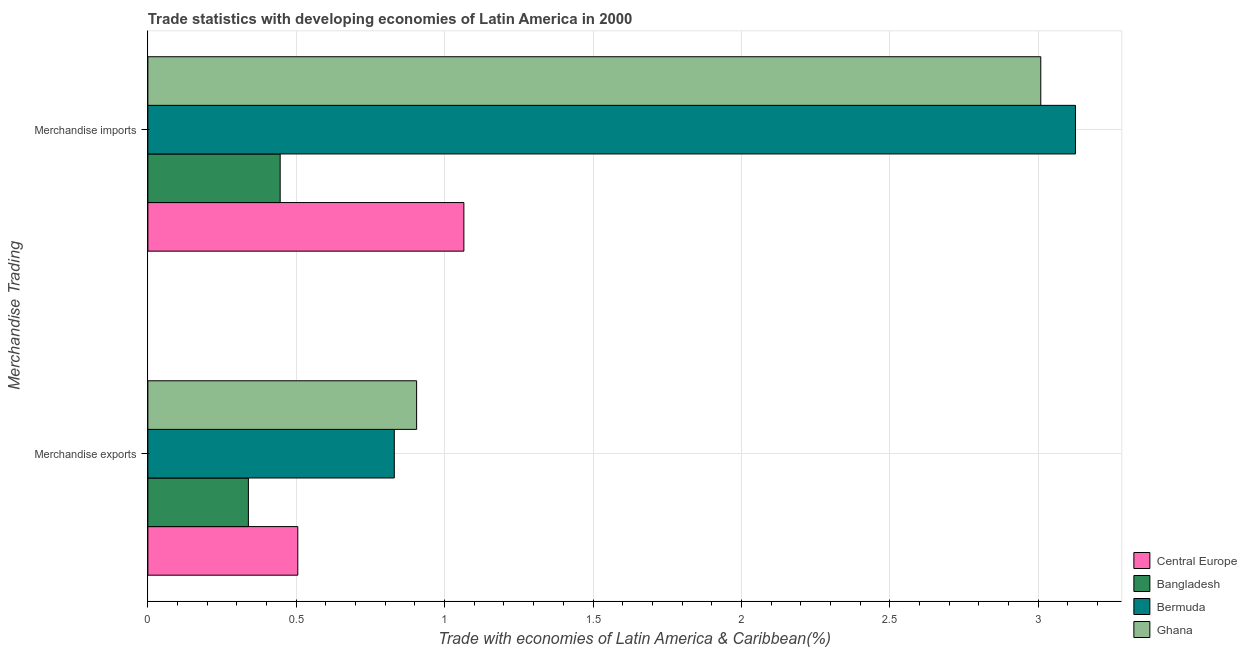Are the number of bars on each tick of the Y-axis equal?
Your answer should be compact. Yes. How many bars are there on the 1st tick from the bottom?
Provide a succinct answer. 4. What is the merchandise imports in Central Europe?
Offer a very short reply. 1.06. Across all countries, what is the maximum merchandise exports?
Offer a terse response. 0.91. Across all countries, what is the minimum merchandise exports?
Offer a terse response. 0.34. In which country was the merchandise imports maximum?
Provide a short and direct response. Bermuda. What is the total merchandise exports in the graph?
Your answer should be very brief. 2.58. What is the difference between the merchandise imports in Bangladesh and that in Bermuda?
Offer a very short reply. -2.68. What is the difference between the merchandise exports in Ghana and the merchandise imports in Bangladesh?
Your response must be concise. 0.46. What is the average merchandise exports per country?
Your response must be concise. 0.65. What is the difference between the merchandise exports and merchandise imports in Central Europe?
Your response must be concise. -0.56. What is the ratio of the merchandise imports in Central Europe to that in Bermuda?
Provide a short and direct response. 0.34. Is the merchandise exports in Bermuda less than that in Ghana?
Keep it short and to the point. Yes. In how many countries, is the merchandise imports greater than the average merchandise imports taken over all countries?
Your answer should be very brief. 2. What does the 3rd bar from the top in Merchandise exports represents?
Offer a terse response. Bangladesh. How many countries are there in the graph?
Provide a succinct answer. 4. What is the difference between two consecutive major ticks on the X-axis?
Provide a short and direct response. 0.5. Does the graph contain any zero values?
Ensure brevity in your answer.  No. Does the graph contain grids?
Your response must be concise. Yes. Where does the legend appear in the graph?
Your answer should be very brief. Bottom right. How many legend labels are there?
Make the answer very short. 4. What is the title of the graph?
Ensure brevity in your answer.  Trade statistics with developing economies of Latin America in 2000. Does "Belize" appear as one of the legend labels in the graph?
Give a very brief answer. No. What is the label or title of the X-axis?
Offer a terse response. Trade with economies of Latin America & Caribbean(%). What is the label or title of the Y-axis?
Ensure brevity in your answer.  Merchandise Trading. What is the Trade with economies of Latin America & Caribbean(%) of Central Europe in Merchandise exports?
Offer a terse response. 0.51. What is the Trade with economies of Latin America & Caribbean(%) in Bangladesh in Merchandise exports?
Give a very brief answer. 0.34. What is the Trade with economies of Latin America & Caribbean(%) in Bermuda in Merchandise exports?
Ensure brevity in your answer.  0.83. What is the Trade with economies of Latin America & Caribbean(%) in Ghana in Merchandise exports?
Offer a very short reply. 0.91. What is the Trade with economies of Latin America & Caribbean(%) of Central Europe in Merchandise imports?
Your response must be concise. 1.06. What is the Trade with economies of Latin America & Caribbean(%) of Bangladesh in Merchandise imports?
Your answer should be very brief. 0.45. What is the Trade with economies of Latin America & Caribbean(%) in Bermuda in Merchandise imports?
Make the answer very short. 3.13. What is the Trade with economies of Latin America & Caribbean(%) in Ghana in Merchandise imports?
Keep it short and to the point. 3.01. Across all Merchandise Trading, what is the maximum Trade with economies of Latin America & Caribbean(%) of Central Europe?
Your response must be concise. 1.06. Across all Merchandise Trading, what is the maximum Trade with economies of Latin America & Caribbean(%) of Bangladesh?
Your response must be concise. 0.45. Across all Merchandise Trading, what is the maximum Trade with economies of Latin America & Caribbean(%) of Bermuda?
Provide a succinct answer. 3.13. Across all Merchandise Trading, what is the maximum Trade with economies of Latin America & Caribbean(%) of Ghana?
Your response must be concise. 3.01. Across all Merchandise Trading, what is the minimum Trade with economies of Latin America & Caribbean(%) of Central Europe?
Your response must be concise. 0.51. Across all Merchandise Trading, what is the minimum Trade with economies of Latin America & Caribbean(%) of Bangladesh?
Your answer should be very brief. 0.34. Across all Merchandise Trading, what is the minimum Trade with economies of Latin America & Caribbean(%) in Bermuda?
Your answer should be very brief. 0.83. Across all Merchandise Trading, what is the minimum Trade with economies of Latin America & Caribbean(%) in Ghana?
Give a very brief answer. 0.91. What is the total Trade with economies of Latin America & Caribbean(%) of Central Europe in the graph?
Provide a short and direct response. 1.57. What is the total Trade with economies of Latin America & Caribbean(%) in Bangladesh in the graph?
Provide a succinct answer. 0.78. What is the total Trade with economies of Latin America & Caribbean(%) in Bermuda in the graph?
Your answer should be compact. 3.96. What is the total Trade with economies of Latin America & Caribbean(%) of Ghana in the graph?
Provide a succinct answer. 3.91. What is the difference between the Trade with economies of Latin America & Caribbean(%) of Central Europe in Merchandise exports and that in Merchandise imports?
Keep it short and to the point. -0.56. What is the difference between the Trade with economies of Latin America & Caribbean(%) of Bangladesh in Merchandise exports and that in Merchandise imports?
Ensure brevity in your answer.  -0.11. What is the difference between the Trade with economies of Latin America & Caribbean(%) in Bermuda in Merchandise exports and that in Merchandise imports?
Keep it short and to the point. -2.3. What is the difference between the Trade with economies of Latin America & Caribbean(%) of Ghana in Merchandise exports and that in Merchandise imports?
Give a very brief answer. -2.1. What is the difference between the Trade with economies of Latin America & Caribbean(%) in Central Europe in Merchandise exports and the Trade with economies of Latin America & Caribbean(%) in Bangladesh in Merchandise imports?
Offer a terse response. 0.06. What is the difference between the Trade with economies of Latin America & Caribbean(%) in Central Europe in Merchandise exports and the Trade with economies of Latin America & Caribbean(%) in Bermuda in Merchandise imports?
Keep it short and to the point. -2.62. What is the difference between the Trade with economies of Latin America & Caribbean(%) in Central Europe in Merchandise exports and the Trade with economies of Latin America & Caribbean(%) in Ghana in Merchandise imports?
Keep it short and to the point. -2.5. What is the difference between the Trade with economies of Latin America & Caribbean(%) in Bangladesh in Merchandise exports and the Trade with economies of Latin America & Caribbean(%) in Bermuda in Merchandise imports?
Your response must be concise. -2.79. What is the difference between the Trade with economies of Latin America & Caribbean(%) in Bangladesh in Merchandise exports and the Trade with economies of Latin America & Caribbean(%) in Ghana in Merchandise imports?
Provide a short and direct response. -2.67. What is the difference between the Trade with economies of Latin America & Caribbean(%) in Bermuda in Merchandise exports and the Trade with economies of Latin America & Caribbean(%) in Ghana in Merchandise imports?
Provide a succinct answer. -2.18. What is the average Trade with economies of Latin America & Caribbean(%) in Central Europe per Merchandise Trading?
Your answer should be compact. 0.79. What is the average Trade with economies of Latin America & Caribbean(%) of Bangladesh per Merchandise Trading?
Make the answer very short. 0.39. What is the average Trade with economies of Latin America & Caribbean(%) of Bermuda per Merchandise Trading?
Make the answer very short. 1.98. What is the average Trade with economies of Latin America & Caribbean(%) in Ghana per Merchandise Trading?
Give a very brief answer. 1.96. What is the difference between the Trade with economies of Latin America & Caribbean(%) in Central Europe and Trade with economies of Latin America & Caribbean(%) in Bangladesh in Merchandise exports?
Your answer should be very brief. 0.17. What is the difference between the Trade with economies of Latin America & Caribbean(%) in Central Europe and Trade with economies of Latin America & Caribbean(%) in Bermuda in Merchandise exports?
Your response must be concise. -0.33. What is the difference between the Trade with economies of Latin America & Caribbean(%) of Central Europe and Trade with economies of Latin America & Caribbean(%) of Ghana in Merchandise exports?
Make the answer very short. -0.4. What is the difference between the Trade with economies of Latin America & Caribbean(%) in Bangladesh and Trade with economies of Latin America & Caribbean(%) in Bermuda in Merchandise exports?
Give a very brief answer. -0.49. What is the difference between the Trade with economies of Latin America & Caribbean(%) of Bangladesh and Trade with economies of Latin America & Caribbean(%) of Ghana in Merchandise exports?
Keep it short and to the point. -0.57. What is the difference between the Trade with economies of Latin America & Caribbean(%) in Bermuda and Trade with economies of Latin America & Caribbean(%) in Ghana in Merchandise exports?
Your answer should be compact. -0.08. What is the difference between the Trade with economies of Latin America & Caribbean(%) in Central Europe and Trade with economies of Latin America & Caribbean(%) in Bangladesh in Merchandise imports?
Your response must be concise. 0.62. What is the difference between the Trade with economies of Latin America & Caribbean(%) in Central Europe and Trade with economies of Latin America & Caribbean(%) in Bermuda in Merchandise imports?
Your answer should be compact. -2.06. What is the difference between the Trade with economies of Latin America & Caribbean(%) in Central Europe and Trade with economies of Latin America & Caribbean(%) in Ghana in Merchandise imports?
Offer a very short reply. -1.94. What is the difference between the Trade with economies of Latin America & Caribbean(%) of Bangladesh and Trade with economies of Latin America & Caribbean(%) of Bermuda in Merchandise imports?
Your answer should be very brief. -2.68. What is the difference between the Trade with economies of Latin America & Caribbean(%) in Bangladesh and Trade with economies of Latin America & Caribbean(%) in Ghana in Merchandise imports?
Offer a very short reply. -2.56. What is the difference between the Trade with economies of Latin America & Caribbean(%) of Bermuda and Trade with economies of Latin America & Caribbean(%) of Ghana in Merchandise imports?
Ensure brevity in your answer.  0.12. What is the ratio of the Trade with economies of Latin America & Caribbean(%) in Central Europe in Merchandise exports to that in Merchandise imports?
Provide a succinct answer. 0.47. What is the ratio of the Trade with economies of Latin America & Caribbean(%) in Bangladesh in Merchandise exports to that in Merchandise imports?
Give a very brief answer. 0.76. What is the ratio of the Trade with economies of Latin America & Caribbean(%) in Bermuda in Merchandise exports to that in Merchandise imports?
Make the answer very short. 0.27. What is the ratio of the Trade with economies of Latin America & Caribbean(%) of Ghana in Merchandise exports to that in Merchandise imports?
Provide a short and direct response. 0.3. What is the difference between the highest and the second highest Trade with economies of Latin America & Caribbean(%) of Central Europe?
Make the answer very short. 0.56. What is the difference between the highest and the second highest Trade with economies of Latin America & Caribbean(%) of Bangladesh?
Make the answer very short. 0.11. What is the difference between the highest and the second highest Trade with economies of Latin America & Caribbean(%) in Bermuda?
Make the answer very short. 2.3. What is the difference between the highest and the second highest Trade with economies of Latin America & Caribbean(%) in Ghana?
Provide a short and direct response. 2.1. What is the difference between the highest and the lowest Trade with economies of Latin America & Caribbean(%) of Central Europe?
Give a very brief answer. 0.56. What is the difference between the highest and the lowest Trade with economies of Latin America & Caribbean(%) in Bangladesh?
Your answer should be very brief. 0.11. What is the difference between the highest and the lowest Trade with economies of Latin America & Caribbean(%) in Bermuda?
Offer a very short reply. 2.3. What is the difference between the highest and the lowest Trade with economies of Latin America & Caribbean(%) of Ghana?
Your answer should be very brief. 2.1. 